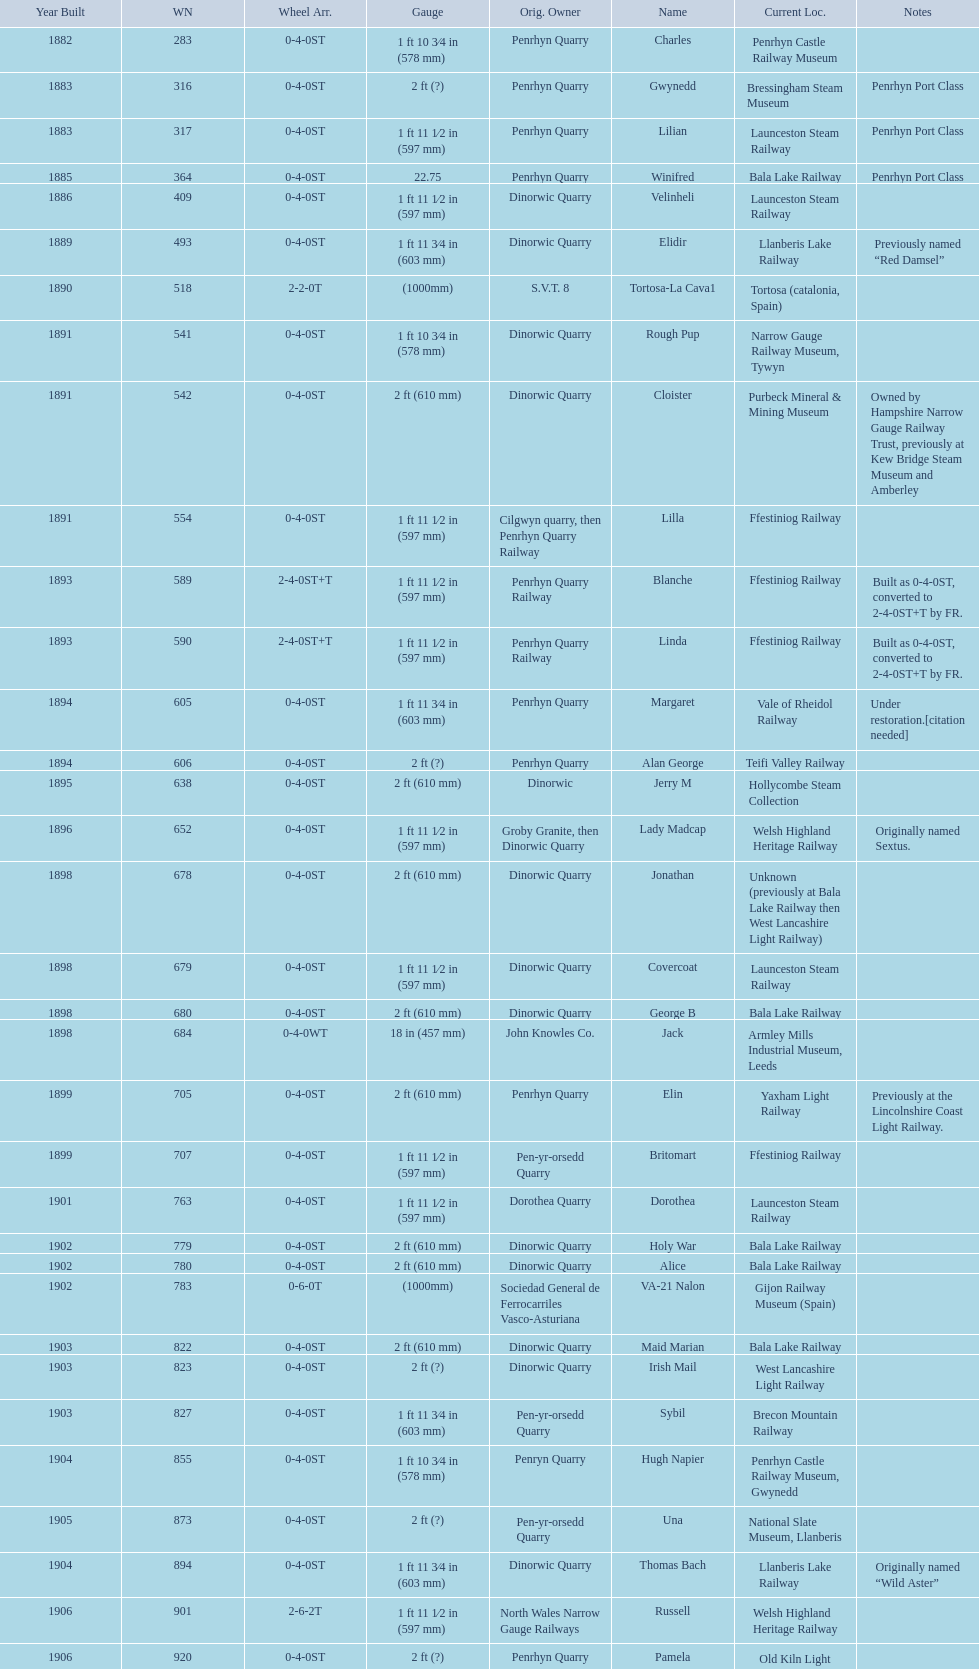Which original owner had the most locomotives? Penrhyn Quarry. 